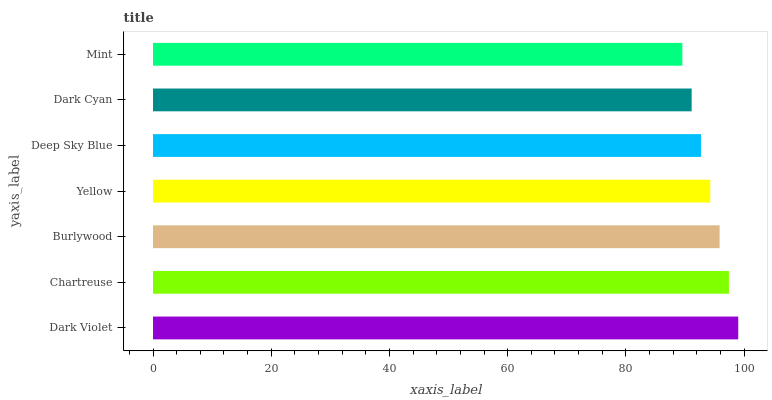Is Mint the minimum?
Answer yes or no. Yes. Is Dark Violet the maximum?
Answer yes or no. Yes. Is Chartreuse the minimum?
Answer yes or no. No. Is Chartreuse the maximum?
Answer yes or no. No. Is Dark Violet greater than Chartreuse?
Answer yes or no. Yes. Is Chartreuse less than Dark Violet?
Answer yes or no. Yes. Is Chartreuse greater than Dark Violet?
Answer yes or no. No. Is Dark Violet less than Chartreuse?
Answer yes or no. No. Is Yellow the high median?
Answer yes or no. Yes. Is Yellow the low median?
Answer yes or no. Yes. Is Burlywood the high median?
Answer yes or no. No. Is Deep Sky Blue the low median?
Answer yes or no. No. 